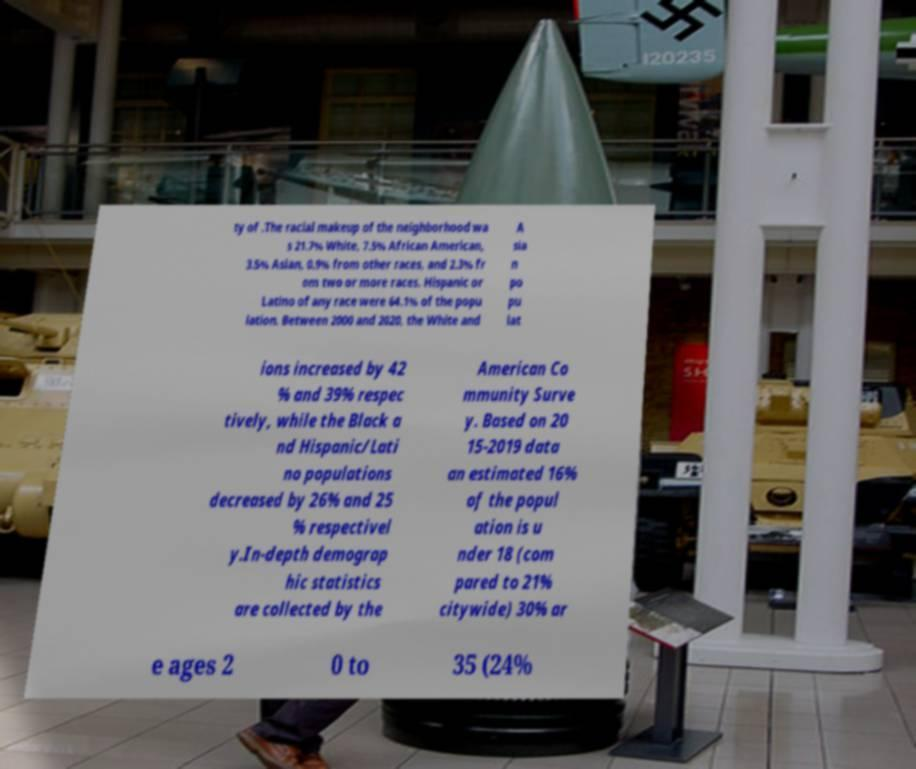Can you accurately transcribe the text from the provided image for me? ty of .The racial makeup of the neighborhood wa s 21.7% White, 7.5% African American, 3.5% Asian, 0.9% from other races, and 2.3% fr om two or more races. Hispanic or Latino of any race were 64.1% of the popu lation. Between 2000 and 2020, the White and A sia n po pu lat ions increased by 42 % and 39% respec tively, while the Black a nd Hispanic/Lati no populations decreased by 26% and 25 % respectivel y.In-depth demograp hic statistics are collected by the American Co mmunity Surve y. Based on 20 15-2019 data an estimated 16% of the popul ation is u nder 18 (com pared to 21% citywide) 30% ar e ages 2 0 to 35 (24% 